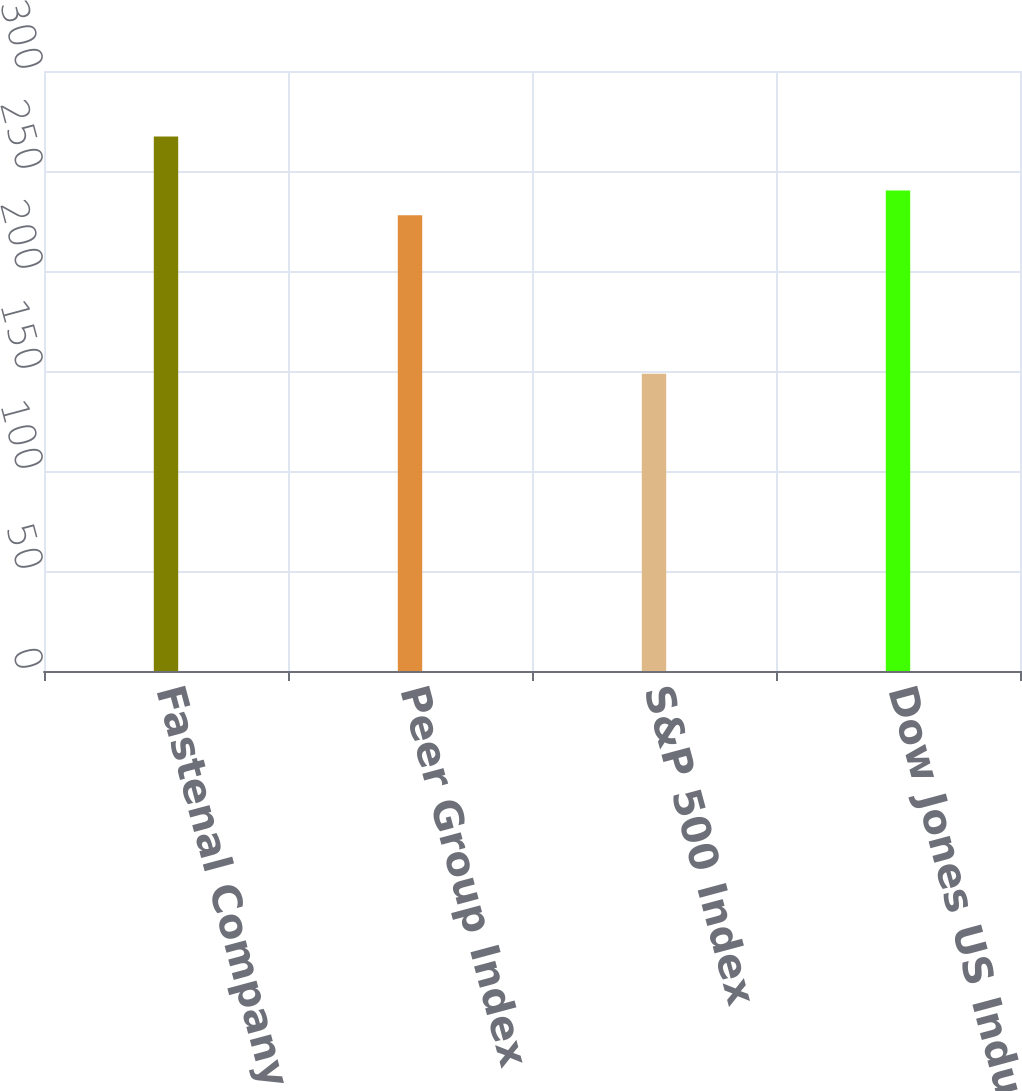Convert chart to OTSL. <chart><loc_0><loc_0><loc_500><loc_500><bar_chart><fcel>Fastenal Company<fcel>Peer Group Index<fcel>S&P 500 Index<fcel>Dow Jones US Industrial<nl><fcel>267.27<fcel>227.82<fcel>148.59<fcel>240.29<nl></chart> 